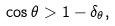Convert formula to latex. <formula><loc_0><loc_0><loc_500><loc_500>\cos \theta > 1 - \delta _ { \theta } ,</formula> 